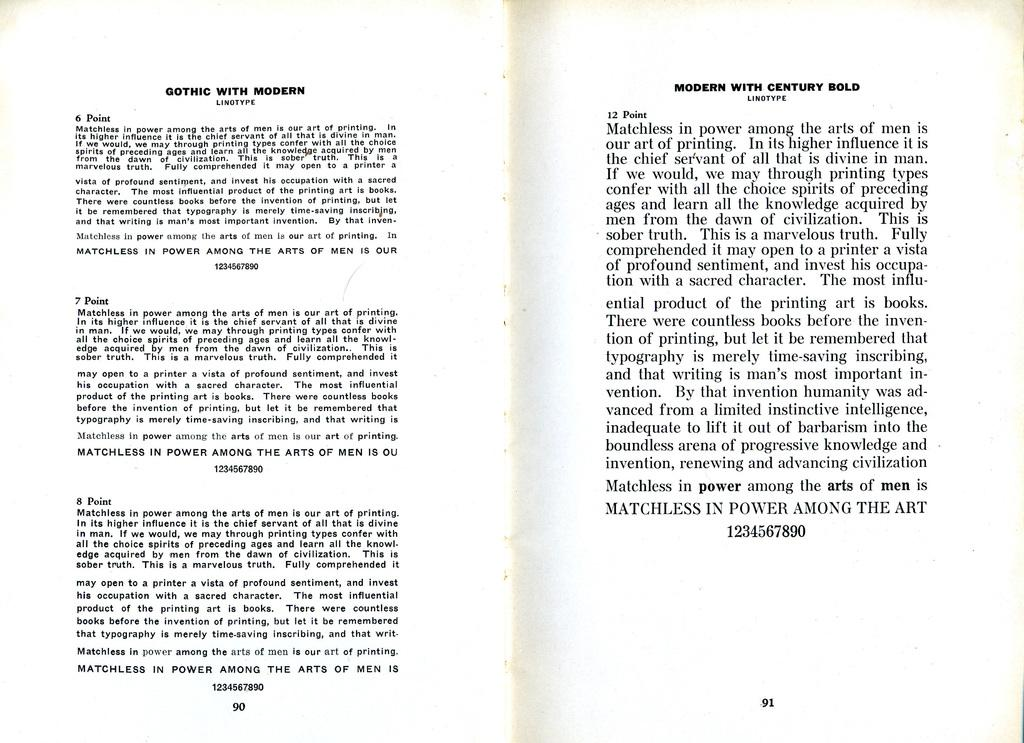<image>
Present a compact description of the photo's key features. Readings from pages 90 and 91 of a book. 